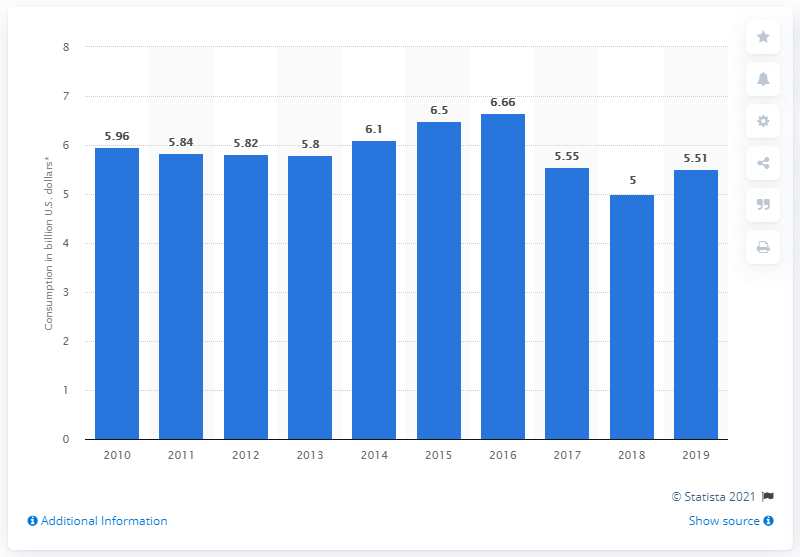Outline some significant characteristics in this image. In 2016, the internal tourism consumption in Puerto Rico was 6.66... In 2019, Puerto Rico's internal travel and tourism consumption was 5.51. 